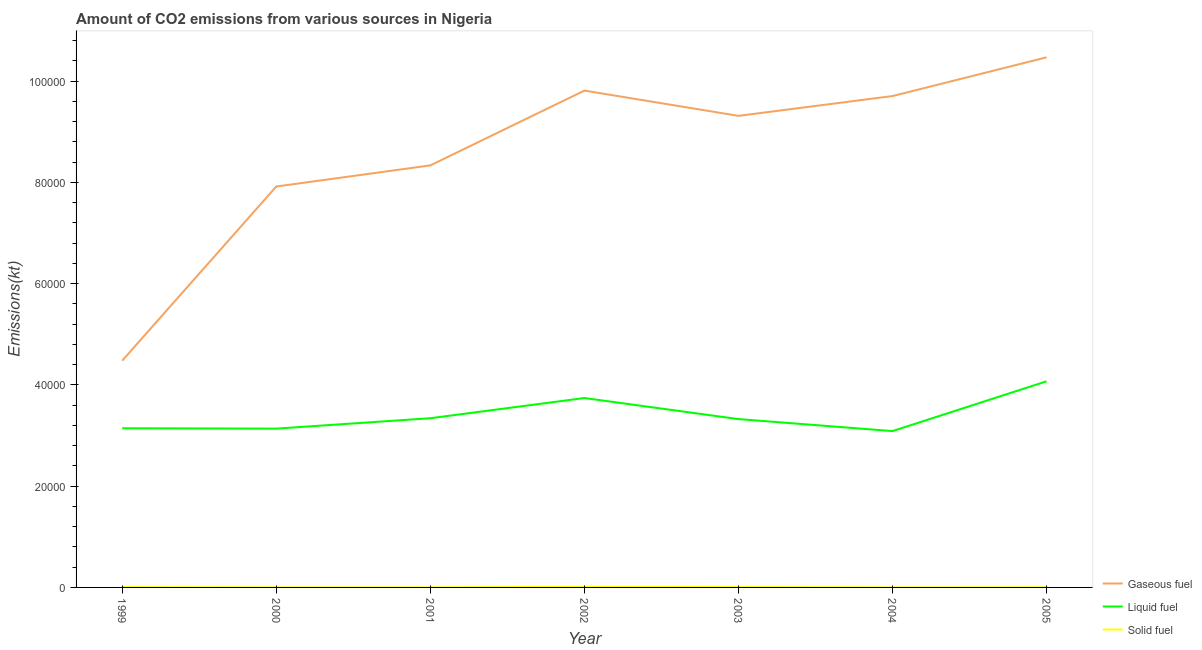Does the line corresponding to amount of co2 emissions from solid fuel intersect with the line corresponding to amount of co2 emissions from gaseous fuel?
Offer a very short reply. No. What is the amount of co2 emissions from solid fuel in 1999?
Your answer should be compact. 55.01. Across all years, what is the maximum amount of co2 emissions from gaseous fuel?
Provide a short and direct response. 1.05e+05. Across all years, what is the minimum amount of co2 emissions from liquid fuel?
Provide a succinct answer. 3.09e+04. In which year was the amount of co2 emissions from liquid fuel maximum?
Provide a succinct answer. 2005. In which year was the amount of co2 emissions from gaseous fuel minimum?
Make the answer very short. 1999. What is the total amount of co2 emissions from gaseous fuel in the graph?
Provide a succinct answer. 6.00e+05. What is the difference between the amount of co2 emissions from gaseous fuel in 2001 and that in 2005?
Your response must be concise. -2.13e+04. What is the difference between the amount of co2 emissions from solid fuel in 2005 and the amount of co2 emissions from liquid fuel in 2001?
Ensure brevity in your answer.  -3.34e+04. What is the average amount of co2 emissions from gaseous fuel per year?
Provide a short and direct response. 8.58e+04. In the year 1999, what is the difference between the amount of co2 emissions from liquid fuel and amount of co2 emissions from gaseous fuel?
Offer a terse response. -1.34e+04. What is the ratio of the amount of co2 emissions from solid fuel in 1999 to that in 2004?
Give a very brief answer. 3.75. Is the difference between the amount of co2 emissions from gaseous fuel in 2003 and 2005 greater than the difference between the amount of co2 emissions from solid fuel in 2003 and 2005?
Offer a very short reply. No. What is the difference between the highest and the second highest amount of co2 emissions from liquid fuel?
Keep it short and to the point. 3303.97. What is the difference between the highest and the lowest amount of co2 emissions from solid fuel?
Make the answer very short. 110.01. In how many years, is the amount of co2 emissions from liquid fuel greater than the average amount of co2 emissions from liquid fuel taken over all years?
Provide a succinct answer. 2. Does the amount of co2 emissions from liquid fuel monotonically increase over the years?
Offer a very short reply. No. Does the graph contain grids?
Your answer should be very brief. No. Where does the legend appear in the graph?
Offer a very short reply. Bottom right. What is the title of the graph?
Your response must be concise. Amount of CO2 emissions from various sources in Nigeria. What is the label or title of the Y-axis?
Provide a succinct answer. Emissions(kt). What is the Emissions(kt) of Gaseous fuel in 1999?
Your answer should be compact. 4.48e+04. What is the Emissions(kt) of Liquid fuel in 1999?
Provide a succinct answer. 3.14e+04. What is the Emissions(kt) in Solid fuel in 1999?
Make the answer very short. 55.01. What is the Emissions(kt) in Gaseous fuel in 2000?
Your answer should be compact. 7.92e+04. What is the Emissions(kt) of Liquid fuel in 2000?
Offer a very short reply. 3.14e+04. What is the Emissions(kt) in Solid fuel in 2000?
Your answer should be compact. 18.34. What is the Emissions(kt) of Gaseous fuel in 2001?
Offer a terse response. 8.34e+04. What is the Emissions(kt) in Liquid fuel in 2001?
Provide a succinct answer. 3.34e+04. What is the Emissions(kt) in Solid fuel in 2001?
Offer a terse response. 18.34. What is the Emissions(kt) of Gaseous fuel in 2002?
Ensure brevity in your answer.  9.81e+04. What is the Emissions(kt) in Liquid fuel in 2002?
Keep it short and to the point. 3.74e+04. What is the Emissions(kt) of Solid fuel in 2002?
Keep it short and to the point. 124.68. What is the Emissions(kt) in Gaseous fuel in 2003?
Your answer should be very brief. 9.31e+04. What is the Emissions(kt) in Liquid fuel in 2003?
Your response must be concise. 3.32e+04. What is the Emissions(kt) in Solid fuel in 2003?
Offer a very short reply. 69.67. What is the Emissions(kt) in Gaseous fuel in 2004?
Keep it short and to the point. 9.70e+04. What is the Emissions(kt) in Liquid fuel in 2004?
Offer a terse response. 3.09e+04. What is the Emissions(kt) of Solid fuel in 2004?
Offer a very short reply. 14.67. What is the Emissions(kt) in Gaseous fuel in 2005?
Your answer should be very brief. 1.05e+05. What is the Emissions(kt) of Liquid fuel in 2005?
Make the answer very short. 4.07e+04. What is the Emissions(kt) of Solid fuel in 2005?
Offer a terse response. 29.34. Across all years, what is the maximum Emissions(kt) in Gaseous fuel?
Ensure brevity in your answer.  1.05e+05. Across all years, what is the maximum Emissions(kt) of Liquid fuel?
Your response must be concise. 4.07e+04. Across all years, what is the maximum Emissions(kt) in Solid fuel?
Provide a succinct answer. 124.68. Across all years, what is the minimum Emissions(kt) of Gaseous fuel?
Your response must be concise. 4.48e+04. Across all years, what is the minimum Emissions(kt) in Liquid fuel?
Your answer should be compact. 3.09e+04. Across all years, what is the minimum Emissions(kt) of Solid fuel?
Your answer should be compact. 14.67. What is the total Emissions(kt) of Gaseous fuel in the graph?
Make the answer very short. 6.00e+05. What is the total Emissions(kt) of Liquid fuel in the graph?
Offer a terse response. 2.38e+05. What is the total Emissions(kt) in Solid fuel in the graph?
Offer a terse response. 330.03. What is the difference between the Emissions(kt) of Gaseous fuel in 1999 and that in 2000?
Make the answer very short. -3.44e+04. What is the difference between the Emissions(kt) in Liquid fuel in 1999 and that in 2000?
Offer a terse response. 69.67. What is the difference between the Emissions(kt) of Solid fuel in 1999 and that in 2000?
Make the answer very short. 36.67. What is the difference between the Emissions(kt) of Gaseous fuel in 1999 and that in 2001?
Keep it short and to the point. -3.86e+04. What is the difference between the Emissions(kt) of Liquid fuel in 1999 and that in 2001?
Ensure brevity in your answer.  -1983.85. What is the difference between the Emissions(kt) of Solid fuel in 1999 and that in 2001?
Your answer should be compact. 36.67. What is the difference between the Emissions(kt) of Gaseous fuel in 1999 and that in 2002?
Provide a short and direct response. -5.33e+04. What is the difference between the Emissions(kt) of Liquid fuel in 1999 and that in 2002?
Provide a short and direct response. -5973.54. What is the difference between the Emissions(kt) of Solid fuel in 1999 and that in 2002?
Your answer should be compact. -69.67. What is the difference between the Emissions(kt) of Gaseous fuel in 1999 and that in 2003?
Offer a terse response. -4.83e+04. What is the difference between the Emissions(kt) in Liquid fuel in 1999 and that in 2003?
Ensure brevity in your answer.  -1815.16. What is the difference between the Emissions(kt) in Solid fuel in 1999 and that in 2003?
Keep it short and to the point. -14.67. What is the difference between the Emissions(kt) of Gaseous fuel in 1999 and that in 2004?
Offer a very short reply. -5.23e+04. What is the difference between the Emissions(kt) in Liquid fuel in 1999 and that in 2004?
Make the answer very short. 557.38. What is the difference between the Emissions(kt) of Solid fuel in 1999 and that in 2004?
Provide a succinct answer. 40.34. What is the difference between the Emissions(kt) of Gaseous fuel in 1999 and that in 2005?
Offer a terse response. -5.99e+04. What is the difference between the Emissions(kt) in Liquid fuel in 1999 and that in 2005?
Your response must be concise. -9277.51. What is the difference between the Emissions(kt) in Solid fuel in 1999 and that in 2005?
Keep it short and to the point. 25.67. What is the difference between the Emissions(kt) in Gaseous fuel in 2000 and that in 2001?
Keep it short and to the point. -4169.38. What is the difference between the Emissions(kt) in Liquid fuel in 2000 and that in 2001?
Provide a short and direct response. -2053.52. What is the difference between the Emissions(kt) in Gaseous fuel in 2000 and that in 2002?
Provide a succinct answer. -1.89e+04. What is the difference between the Emissions(kt) of Liquid fuel in 2000 and that in 2002?
Give a very brief answer. -6043.22. What is the difference between the Emissions(kt) of Solid fuel in 2000 and that in 2002?
Provide a short and direct response. -106.34. What is the difference between the Emissions(kt) in Gaseous fuel in 2000 and that in 2003?
Make the answer very short. -1.40e+04. What is the difference between the Emissions(kt) of Liquid fuel in 2000 and that in 2003?
Your response must be concise. -1884.84. What is the difference between the Emissions(kt) in Solid fuel in 2000 and that in 2003?
Make the answer very short. -51.34. What is the difference between the Emissions(kt) of Gaseous fuel in 2000 and that in 2004?
Ensure brevity in your answer.  -1.79e+04. What is the difference between the Emissions(kt) of Liquid fuel in 2000 and that in 2004?
Your answer should be compact. 487.71. What is the difference between the Emissions(kt) in Solid fuel in 2000 and that in 2004?
Keep it short and to the point. 3.67. What is the difference between the Emissions(kt) of Gaseous fuel in 2000 and that in 2005?
Keep it short and to the point. -2.55e+04. What is the difference between the Emissions(kt) in Liquid fuel in 2000 and that in 2005?
Your answer should be compact. -9347.18. What is the difference between the Emissions(kt) of Solid fuel in 2000 and that in 2005?
Offer a terse response. -11. What is the difference between the Emissions(kt) in Gaseous fuel in 2001 and that in 2002?
Offer a terse response. -1.48e+04. What is the difference between the Emissions(kt) of Liquid fuel in 2001 and that in 2002?
Make the answer very short. -3989.7. What is the difference between the Emissions(kt) of Solid fuel in 2001 and that in 2002?
Your response must be concise. -106.34. What is the difference between the Emissions(kt) of Gaseous fuel in 2001 and that in 2003?
Your answer should be very brief. -9787.22. What is the difference between the Emissions(kt) in Liquid fuel in 2001 and that in 2003?
Offer a very short reply. 168.68. What is the difference between the Emissions(kt) in Solid fuel in 2001 and that in 2003?
Provide a succinct answer. -51.34. What is the difference between the Emissions(kt) in Gaseous fuel in 2001 and that in 2004?
Your answer should be compact. -1.37e+04. What is the difference between the Emissions(kt) of Liquid fuel in 2001 and that in 2004?
Keep it short and to the point. 2541.23. What is the difference between the Emissions(kt) in Solid fuel in 2001 and that in 2004?
Your answer should be very brief. 3.67. What is the difference between the Emissions(kt) of Gaseous fuel in 2001 and that in 2005?
Offer a very short reply. -2.13e+04. What is the difference between the Emissions(kt) in Liquid fuel in 2001 and that in 2005?
Provide a short and direct response. -7293.66. What is the difference between the Emissions(kt) in Solid fuel in 2001 and that in 2005?
Your response must be concise. -11. What is the difference between the Emissions(kt) in Gaseous fuel in 2002 and that in 2003?
Ensure brevity in your answer.  4987.12. What is the difference between the Emissions(kt) of Liquid fuel in 2002 and that in 2003?
Offer a terse response. 4158.38. What is the difference between the Emissions(kt) in Solid fuel in 2002 and that in 2003?
Your answer should be very brief. 55.01. What is the difference between the Emissions(kt) in Gaseous fuel in 2002 and that in 2004?
Make the answer very short. 1078.1. What is the difference between the Emissions(kt) in Liquid fuel in 2002 and that in 2004?
Make the answer very short. 6530.93. What is the difference between the Emissions(kt) in Solid fuel in 2002 and that in 2004?
Keep it short and to the point. 110.01. What is the difference between the Emissions(kt) in Gaseous fuel in 2002 and that in 2005?
Make the answer very short. -6571.26. What is the difference between the Emissions(kt) of Liquid fuel in 2002 and that in 2005?
Make the answer very short. -3303.97. What is the difference between the Emissions(kt) in Solid fuel in 2002 and that in 2005?
Make the answer very short. 95.34. What is the difference between the Emissions(kt) in Gaseous fuel in 2003 and that in 2004?
Provide a succinct answer. -3909.02. What is the difference between the Emissions(kt) in Liquid fuel in 2003 and that in 2004?
Offer a very short reply. 2372.55. What is the difference between the Emissions(kt) in Solid fuel in 2003 and that in 2004?
Offer a very short reply. 55.01. What is the difference between the Emissions(kt) of Gaseous fuel in 2003 and that in 2005?
Make the answer very short. -1.16e+04. What is the difference between the Emissions(kt) of Liquid fuel in 2003 and that in 2005?
Your response must be concise. -7462.35. What is the difference between the Emissions(kt) in Solid fuel in 2003 and that in 2005?
Provide a short and direct response. 40.34. What is the difference between the Emissions(kt) of Gaseous fuel in 2004 and that in 2005?
Your answer should be compact. -7649.36. What is the difference between the Emissions(kt) of Liquid fuel in 2004 and that in 2005?
Give a very brief answer. -9834.89. What is the difference between the Emissions(kt) in Solid fuel in 2004 and that in 2005?
Provide a succinct answer. -14.67. What is the difference between the Emissions(kt) of Gaseous fuel in 1999 and the Emissions(kt) of Liquid fuel in 2000?
Your response must be concise. 1.34e+04. What is the difference between the Emissions(kt) of Gaseous fuel in 1999 and the Emissions(kt) of Solid fuel in 2000?
Keep it short and to the point. 4.48e+04. What is the difference between the Emissions(kt) in Liquid fuel in 1999 and the Emissions(kt) in Solid fuel in 2000?
Your answer should be compact. 3.14e+04. What is the difference between the Emissions(kt) in Gaseous fuel in 1999 and the Emissions(kt) in Liquid fuel in 2001?
Offer a very short reply. 1.14e+04. What is the difference between the Emissions(kt) in Gaseous fuel in 1999 and the Emissions(kt) in Solid fuel in 2001?
Your response must be concise. 4.48e+04. What is the difference between the Emissions(kt) of Liquid fuel in 1999 and the Emissions(kt) of Solid fuel in 2001?
Give a very brief answer. 3.14e+04. What is the difference between the Emissions(kt) in Gaseous fuel in 1999 and the Emissions(kt) in Liquid fuel in 2002?
Provide a short and direct response. 7381.67. What is the difference between the Emissions(kt) in Gaseous fuel in 1999 and the Emissions(kt) in Solid fuel in 2002?
Make the answer very short. 4.47e+04. What is the difference between the Emissions(kt) in Liquid fuel in 1999 and the Emissions(kt) in Solid fuel in 2002?
Make the answer very short. 3.13e+04. What is the difference between the Emissions(kt) of Gaseous fuel in 1999 and the Emissions(kt) of Liquid fuel in 2003?
Offer a terse response. 1.15e+04. What is the difference between the Emissions(kt) of Gaseous fuel in 1999 and the Emissions(kt) of Solid fuel in 2003?
Provide a succinct answer. 4.47e+04. What is the difference between the Emissions(kt) of Liquid fuel in 1999 and the Emissions(kt) of Solid fuel in 2003?
Make the answer very short. 3.14e+04. What is the difference between the Emissions(kt) of Gaseous fuel in 1999 and the Emissions(kt) of Liquid fuel in 2004?
Ensure brevity in your answer.  1.39e+04. What is the difference between the Emissions(kt) of Gaseous fuel in 1999 and the Emissions(kt) of Solid fuel in 2004?
Your response must be concise. 4.48e+04. What is the difference between the Emissions(kt) of Liquid fuel in 1999 and the Emissions(kt) of Solid fuel in 2004?
Your response must be concise. 3.14e+04. What is the difference between the Emissions(kt) in Gaseous fuel in 1999 and the Emissions(kt) in Liquid fuel in 2005?
Make the answer very short. 4077.7. What is the difference between the Emissions(kt) of Gaseous fuel in 1999 and the Emissions(kt) of Solid fuel in 2005?
Ensure brevity in your answer.  4.48e+04. What is the difference between the Emissions(kt) of Liquid fuel in 1999 and the Emissions(kt) of Solid fuel in 2005?
Your answer should be very brief. 3.14e+04. What is the difference between the Emissions(kt) in Gaseous fuel in 2000 and the Emissions(kt) in Liquid fuel in 2001?
Offer a terse response. 4.58e+04. What is the difference between the Emissions(kt) of Gaseous fuel in 2000 and the Emissions(kt) of Solid fuel in 2001?
Make the answer very short. 7.92e+04. What is the difference between the Emissions(kt) in Liquid fuel in 2000 and the Emissions(kt) in Solid fuel in 2001?
Keep it short and to the point. 3.13e+04. What is the difference between the Emissions(kt) of Gaseous fuel in 2000 and the Emissions(kt) of Liquid fuel in 2002?
Ensure brevity in your answer.  4.18e+04. What is the difference between the Emissions(kt) of Gaseous fuel in 2000 and the Emissions(kt) of Solid fuel in 2002?
Make the answer very short. 7.91e+04. What is the difference between the Emissions(kt) of Liquid fuel in 2000 and the Emissions(kt) of Solid fuel in 2002?
Make the answer very short. 3.12e+04. What is the difference between the Emissions(kt) in Gaseous fuel in 2000 and the Emissions(kt) in Liquid fuel in 2003?
Give a very brief answer. 4.59e+04. What is the difference between the Emissions(kt) of Gaseous fuel in 2000 and the Emissions(kt) of Solid fuel in 2003?
Ensure brevity in your answer.  7.91e+04. What is the difference between the Emissions(kt) in Liquid fuel in 2000 and the Emissions(kt) in Solid fuel in 2003?
Your answer should be very brief. 3.13e+04. What is the difference between the Emissions(kt) of Gaseous fuel in 2000 and the Emissions(kt) of Liquid fuel in 2004?
Give a very brief answer. 4.83e+04. What is the difference between the Emissions(kt) of Gaseous fuel in 2000 and the Emissions(kt) of Solid fuel in 2004?
Offer a terse response. 7.92e+04. What is the difference between the Emissions(kt) of Liquid fuel in 2000 and the Emissions(kt) of Solid fuel in 2004?
Offer a very short reply. 3.13e+04. What is the difference between the Emissions(kt) of Gaseous fuel in 2000 and the Emissions(kt) of Liquid fuel in 2005?
Make the answer very short. 3.85e+04. What is the difference between the Emissions(kt) in Gaseous fuel in 2000 and the Emissions(kt) in Solid fuel in 2005?
Provide a short and direct response. 7.92e+04. What is the difference between the Emissions(kt) in Liquid fuel in 2000 and the Emissions(kt) in Solid fuel in 2005?
Offer a terse response. 3.13e+04. What is the difference between the Emissions(kt) in Gaseous fuel in 2001 and the Emissions(kt) in Liquid fuel in 2002?
Keep it short and to the point. 4.59e+04. What is the difference between the Emissions(kt) in Gaseous fuel in 2001 and the Emissions(kt) in Solid fuel in 2002?
Provide a short and direct response. 8.32e+04. What is the difference between the Emissions(kt) in Liquid fuel in 2001 and the Emissions(kt) in Solid fuel in 2002?
Provide a short and direct response. 3.33e+04. What is the difference between the Emissions(kt) of Gaseous fuel in 2001 and the Emissions(kt) of Liquid fuel in 2003?
Keep it short and to the point. 5.01e+04. What is the difference between the Emissions(kt) in Gaseous fuel in 2001 and the Emissions(kt) in Solid fuel in 2003?
Your response must be concise. 8.33e+04. What is the difference between the Emissions(kt) of Liquid fuel in 2001 and the Emissions(kt) of Solid fuel in 2003?
Your response must be concise. 3.33e+04. What is the difference between the Emissions(kt) of Gaseous fuel in 2001 and the Emissions(kt) of Liquid fuel in 2004?
Your answer should be compact. 5.25e+04. What is the difference between the Emissions(kt) of Gaseous fuel in 2001 and the Emissions(kt) of Solid fuel in 2004?
Keep it short and to the point. 8.33e+04. What is the difference between the Emissions(kt) of Liquid fuel in 2001 and the Emissions(kt) of Solid fuel in 2004?
Provide a short and direct response. 3.34e+04. What is the difference between the Emissions(kt) in Gaseous fuel in 2001 and the Emissions(kt) in Liquid fuel in 2005?
Keep it short and to the point. 4.26e+04. What is the difference between the Emissions(kt) in Gaseous fuel in 2001 and the Emissions(kt) in Solid fuel in 2005?
Provide a succinct answer. 8.33e+04. What is the difference between the Emissions(kt) of Liquid fuel in 2001 and the Emissions(kt) of Solid fuel in 2005?
Make the answer very short. 3.34e+04. What is the difference between the Emissions(kt) in Gaseous fuel in 2002 and the Emissions(kt) in Liquid fuel in 2003?
Make the answer very short. 6.49e+04. What is the difference between the Emissions(kt) of Gaseous fuel in 2002 and the Emissions(kt) of Solid fuel in 2003?
Your answer should be compact. 9.81e+04. What is the difference between the Emissions(kt) of Liquid fuel in 2002 and the Emissions(kt) of Solid fuel in 2003?
Your answer should be compact. 3.73e+04. What is the difference between the Emissions(kt) in Gaseous fuel in 2002 and the Emissions(kt) in Liquid fuel in 2004?
Your answer should be very brief. 6.72e+04. What is the difference between the Emissions(kt) of Gaseous fuel in 2002 and the Emissions(kt) of Solid fuel in 2004?
Your answer should be compact. 9.81e+04. What is the difference between the Emissions(kt) in Liquid fuel in 2002 and the Emissions(kt) in Solid fuel in 2004?
Your response must be concise. 3.74e+04. What is the difference between the Emissions(kt) in Gaseous fuel in 2002 and the Emissions(kt) in Liquid fuel in 2005?
Offer a terse response. 5.74e+04. What is the difference between the Emissions(kt) in Gaseous fuel in 2002 and the Emissions(kt) in Solid fuel in 2005?
Give a very brief answer. 9.81e+04. What is the difference between the Emissions(kt) in Liquid fuel in 2002 and the Emissions(kt) in Solid fuel in 2005?
Your answer should be compact. 3.74e+04. What is the difference between the Emissions(kt) in Gaseous fuel in 2003 and the Emissions(kt) in Liquid fuel in 2004?
Provide a short and direct response. 6.23e+04. What is the difference between the Emissions(kt) in Gaseous fuel in 2003 and the Emissions(kt) in Solid fuel in 2004?
Provide a succinct answer. 9.31e+04. What is the difference between the Emissions(kt) of Liquid fuel in 2003 and the Emissions(kt) of Solid fuel in 2004?
Ensure brevity in your answer.  3.32e+04. What is the difference between the Emissions(kt) of Gaseous fuel in 2003 and the Emissions(kt) of Liquid fuel in 2005?
Ensure brevity in your answer.  5.24e+04. What is the difference between the Emissions(kt) in Gaseous fuel in 2003 and the Emissions(kt) in Solid fuel in 2005?
Offer a very short reply. 9.31e+04. What is the difference between the Emissions(kt) in Liquid fuel in 2003 and the Emissions(kt) in Solid fuel in 2005?
Provide a succinct answer. 3.32e+04. What is the difference between the Emissions(kt) of Gaseous fuel in 2004 and the Emissions(kt) of Liquid fuel in 2005?
Ensure brevity in your answer.  5.63e+04. What is the difference between the Emissions(kt) of Gaseous fuel in 2004 and the Emissions(kt) of Solid fuel in 2005?
Your answer should be compact. 9.70e+04. What is the difference between the Emissions(kt) of Liquid fuel in 2004 and the Emissions(kt) of Solid fuel in 2005?
Make the answer very short. 3.08e+04. What is the average Emissions(kt) in Gaseous fuel per year?
Give a very brief answer. 8.58e+04. What is the average Emissions(kt) of Liquid fuel per year?
Offer a very short reply. 3.41e+04. What is the average Emissions(kt) in Solid fuel per year?
Offer a terse response. 47.15. In the year 1999, what is the difference between the Emissions(kt) of Gaseous fuel and Emissions(kt) of Liquid fuel?
Your response must be concise. 1.34e+04. In the year 1999, what is the difference between the Emissions(kt) of Gaseous fuel and Emissions(kt) of Solid fuel?
Offer a very short reply. 4.47e+04. In the year 1999, what is the difference between the Emissions(kt) in Liquid fuel and Emissions(kt) in Solid fuel?
Keep it short and to the point. 3.14e+04. In the year 2000, what is the difference between the Emissions(kt) of Gaseous fuel and Emissions(kt) of Liquid fuel?
Ensure brevity in your answer.  4.78e+04. In the year 2000, what is the difference between the Emissions(kt) in Gaseous fuel and Emissions(kt) in Solid fuel?
Ensure brevity in your answer.  7.92e+04. In the year 2000, what is the difference between the Emissions(kt) in Liquid fuel and Emissions(kt) in Solid fuel?
Provide a succinct answer. 3.13e+04. In the year 2001, what is the difference between the Emissions(kt) in Gaseous fuel and Emissions(kt) in Liquid fuel?
Keep it short and to the point. 4.99e+04. In the year 2001, what is the difference between the Emissions(kt) of Gaseous fuel and Emissions(kt) of Solid fuel?
Ensure brevity in your answer.  8.33e+04. In the year 2001, what is the difference between the Emissions(kt) in Liquid fuel and Emissions(kt) in Solid fuel?
Your answer should be very brief. 3.34e+04. In the year 2002, what is the difference between the Emissions(kt) of Gaseous fuel and Emissions(kt) of Liquid fuel?
Your answer should be compact. 6.07e+04. In the year 2002, what is the difference between the Emissions(kt) in Gaseous fuel and Emissions(kt) in Solid fuel?
Your response must be concise. 9.80e+04. In the year 2002, what is the difference between the Emissions(kt) of Liquid fuel and Emissions(kt) of Solid fuel?
Give a very brief answer. 3.73e+04. In the year 2003, what is the difference between the Emissions(kt) of Gaseous fuel and Emissions(kt) of Liquid fuel?
Your answer should be very brief. 5.99e+04. In the year 2003, what is the difference between the Emissions(kt) in Gaseous fuel and Emissions(kt) in Solid fuel?
Offer a terse response. 9.31e+04. In the year 2003, what is the difference between the Emissions(kt) in Liquid fuel and Emissions(kt) in Solid fuel?
Your response must be concise. 3.32e+04. In the year 2004, what is the difference between the Emissions(kt) in Gaseous fuel and Emissions(kt) in Liquid fuel?
Offer a terse response. 6.62e+04. In the year 2004, what is the difference between the Emissions(kt) in Gaseous fuel and Emissions(kt) in Solid fuel?
Your answer should be very brief. 9.70e+04. In the year 2004, what is the difference between the Emissions(kt) in Liquid fuel and Emissions(kt) in Solid fuel?
Offer a very short reply. 3.09e+04. In the year 2005, what is the difference between the Emissions(kt) in Gaseous fuel and Emissions(kt) in Liquid fuel?
Provide a succinct answer. 6.40e+04. In the year 2005, what is the difference between the Emissions(kt) of Gaseous fuel and Emissions(kt) of Solid fuel?
Make the answer very short. 1.05e+05. In the year 2005, what is the difference between the Emissions(kt) of Liquid fuel and Emissions(kt) of Solid fuel?
Your response must be concise. 4.07e+04. What is the ratio of the Emissions(kt) in Gaseous fuel in 1999 to that in 2000?
Your answer should be very brief. 0.57. What is the ratio of the Emissions(kt) in Gaseous fuel in 1999 to that in 2001?
Provide a short and direct response. 0.54. What is the ratio of the Emissions(kt) in Liquid fuel in 1999 to that in 2001?
Give a very brief answer. 0.94. What is the ratio of the Emissions(kt) of Solid fuel in 1999 to that in 2001?
Give a very brief answer. 3. What is the ratio of the Emissions(kt) of Gaseous fuel in 1999 to that in 2002?
Make the answer very short. 0.46. What is the ratio of the Emissions(kt) of Liquid fuel in 1999 to that in 2002?
Offer a very short reply. 0.84. What is the ratio of the Emissions(kt) in Solid fuel in 1999 to that in 2002?
Make the answer very short. 0.44. What is the ratio of the Emissions(kt) of Gaseous fuel in 1999 to that in 2003?
Ensure brevity in your answer.  0.48. What is the ratio of the Emissions(kt) in Liquid fuel in 1999 to that in 2003?
Offer a terse response. 0.95. What is the ratio of the Emissions(kt) in Solid fuel in 1999 to that in 2003?
Offer a very short reply. 0.79. What is the ratio of the Emissions(kt) of Gaseous fuel in 1999 to that in 2004?
Ensure brevity in your answer.  0.46. What is the ratio of the Emissions(kt) in Liquid fuel in 1999 to that in 2004?
Your response must be concise. 1.02. What is the ratio of the Emissions(kt) of Solid fuel in 1999 to that in 2004?
Offer a terse response. 3.75. What is the ratio of the Emissions(kt) of Gaseous fuel in 1999 to that in 2005?
Provide a succinct answer. 0.43. What is the ratio of the Emissions(kt) in Liquid fuel in 1999 to that in 2005?
Offer a terse response. 0.77. What is the ratio of the Emissions(kt) of Solid fuel in 1999 to that in 2005?
Provide a short and direct response. 1.88. What is the ratio of the Emissions(kt) of Gaseous fuel in 2000 to that in 2001?
Give a very brief answer. 0.95. What is the ratio of the Emissions(kt) of Liquid fuel in 2000 to that in 2001?
Provide a succinct answer. 0.94. What is the ratio of the Emissions(kt) of Gaseous fuel in 2000 to that in 2002?
Offer a very short reply. 0.81. What is the ratio of the Emissions(kt) of Liquid fuel in 2000 to that in 2002?
Keep it short and to the point. 0.84. What is the ratio of the Emissions(kt) of Solid fuel in 2000 to that in 2002?
Offer a very short reply. 0.15. What is the ratio of the Emissions(kt) in Gaseous fuel in 2000 to that in 2003?
Offer a terse response. 0.85. What is the ratio of the Emissions(kt) in Liquid fuel in 2000 to that in 2003?
Your response must be concise. 0.94. What is the ratio of the Emissions(kt) of Solid fuel in 2000 to that in 2003?
Ensure brevity in your answer.  0.26. What is the ratio of the Emissions(kt) in Gaseous fuel in 2000 to that in 2004?
Give a very brief answer. 0.82. What is the ratio of the Emissions(kt) of Liquid fuel in 2000 to that in 2004?
Give a very brief answer. 1.02. What is the ratio of the Emissions(kt) of Gaseous fuel in 2000 to that in 2005?
Provide a short and direct response. 0.76. What is the ratio of the Emissions(kt) of Liquid fuel in 2000 to that in 2005?
Provide a short and direct response. 0.77. What is the ratio of the Emissions(kt) of Gaseous fuel in 2001 to that in 2002?
Offer a terse response. 0.85. What is the ratio of the Emissions(kt) of Liquid fuel in 2001 to that in 2002?
Offer a terse response. 0.89. What is the ratio of the Emissions(kt) in Solid fuel in 2001 to that in 2002?
Your response must be concise. 0.15. What is the ratio of the Emissions(kt) in Gaseous fuel in 2001 to that in 2003?
Your response must be concise. 0.89. What is the ratio of the Emissions(kt) in Liquid fuel in 2001 to that in 2003?
Provide a short and direct response. 1.01. What is the ratio of the Emissions(kt) of Solid fuel in 2001 to that in 2003?
Your answer should be compact. 0.26. What is the ratio of the Emissions(kt) of Gaseous fuel in 2001 to that in 2004?
Provide a succinct answer. 0.86. What is the ratio of the Emissions(kt) of Liquid fuel in 2001 to that in 2004?
Your answer should be very brief. 1.08. What is the ratio of the Emissions(kt) of Gaseous fuel in 2001 to that in 2005?
Keep it short and to the point. 0.8. What is the ratio of the Emissions(kt) in Liquid fuel in 2001 to that in 2005?
Offer a terse response. 0.82. What is the ratio of the Emissions(kt) of Solid fuel in 2001 to that in 2005?
Make the answer very short. 0.62. What is the ratio of the Emissions(kt) in Gaseous fuel in 2002 to that in 2003?
Give a very brief answer. 1.05. What is the ratio of the Emissions(kt) in Liquid fuel in 2002 to that in 2003?
Give a very brief answer. 1.13. What is the ratio of the Emissions(kt) of Solid fuel in 2002 to that in 2003?
Your answer should be compact. 1.79. What is the ratio of the Emissions(kt) in Gaseous fuel in 2002 to that in 2004?
Your response must be concise. 1.01. What is the ratio of the Emissions(kt) in Liquid fuel in 2002 to that in 2004?
Keep it short and to the point. 1.21. What is the ratio of the Emissions(kt) of Gaseous fuel in 2002 to that in 2005?
Provide a succinct answer. 0.94. What is the ratio of the Emissions(kt) in Liquid fuel in 2002 to that in 2005?
Provide a short and direct response. 0.92. What is the ratio of the Emissions(kt) of Solid fuel in 2002 to that in 2005?
Your answer should be compact. 4.25. What is the ratio of the Emissions(kt) of Gaseous fuel in 2003 to that in 2004?
Your response must be concise. 0.96. What is the ratio of the Emissions(kt) of Liquid fuel in 2003 to that in 2004?
Your answer should be very brief. 1.08. What is the ratio of the Emissions(kt) in Solid fuel in 2003 to that in 2004?
Offer a terse response. 4.75. What is the ratio of the Emissions(kt) of Gaseous fuel in 2003 to that in 2005?
Offer a terse response. 0.89. What is the ratio of the Emissions(kt) in Liquid fuel in 2003 to that in 2005?
Ensure brevity in your answer.  0.82. What is the ratio of the Emissions(kt) of Solid fuel in 2003 to that in 2005?
Offer a very short reply. 2.38. What is the ratio of the Emissions(kt) in Gaseous fuel in 2004 to that in 2005?
Provide a short and direct response. 0.93. What is the ratio of the Emissions(kt) of Liquid fuel in 2004 to that in 2005?
Make the answer very short. 0.76. What is the difference between the highest and the second highest Emissions(kt) of Gaseous fuel?
Your response must be concise. 6571.26. What is the difference between the highest and the second highest Emissions(kt) of Liquid fuel?
Give a very brief answer. 3303.97. What is the difference between the highest and the second highest Emissions(kt) of Solid fuel?
Make the answer very short. 55.01. What is the difference between the highest and the lowest Emissions(kt) in Gaseous fuel?
Offer a very short reply. 5.99e+04. What is the difference between the highest and the lowest Emissions(kt) of Liquid fuel?
Your answer should be compact. 9834.89. What is the difference between the highest and the lowest Emissions(kt) of Solid fuel?
Your answer should be very brief. 110.01. 